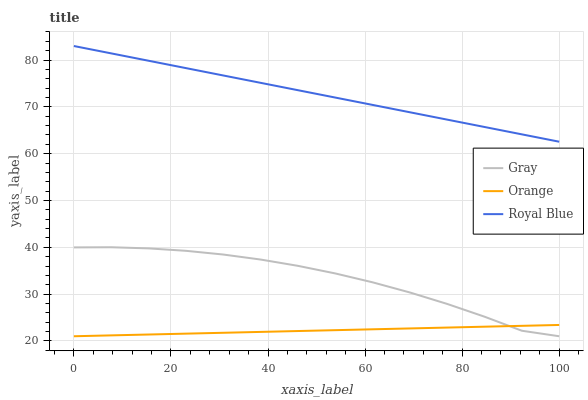Does Orange have the minimum area under the curve?
Answer yes or no. Yes. Does Royal Blue have the maximum area under the curve?
Answer yes or no. Yes. Does Gray have the minimum area under the curve?
Answer yes or no. No. Does Gray have the maximum area under the curve?
Answer yes or no. No. Is Orange the smoothest?
Answer yes or no. Yes. Is Gray the roughest?
Answer yes or no. Yes. Is Royal Blue the smoothest?
Answer yes or no. No. Is Royal Blue the roughest?
Answer yes or no. No. Does Orange have the lowest value?
Answer yes or no. Yes. Does Royal Blue have the lowest value?
Answer yes or no. No. Does Royal Blue have the highest value?
Answer yes or no. Yes. Does Gray have the highest value?
Answer yes or no. No. Is Orange less than Royal Blue?
Answer yes or no. Yes. Is Royal Blue greater than Gray?
Answer yes or no. Yes. Does Gray intersect Orange?
Answer yes or no. Yes. Is Gray less than Orange?
Answer yes or no. No. Is Gray greater than Orange?
Answer yes or no. No. Does Orange intersect Royal Blue?
Answer yes or no. No. 